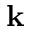Convert formula to latex. <formula><loc_0><loc_0><loc_500><loc_500>k</formula> 